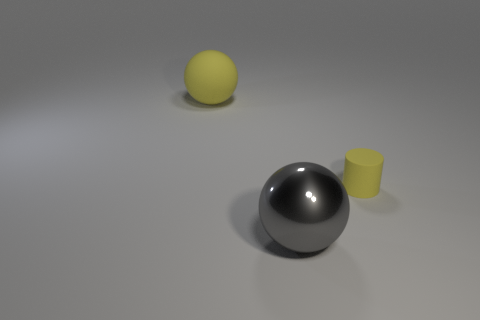What is the material of the large thing that is in front of the yellow object that is in front of the rubber ball that is left of the tiny matte cylinder?
Ensure brevity in your answer.  Metal. How many matte objects are there?
Provide a succinct answer. 2. How many purple things are either spheres or large shiny balls?
Ensure brevity in your answer.  0. What number of other objects are there of the same shape as the small yellow object?
Make the answer very short. 0. Is the color of the matte object that is to the right of the yellow rubber sphere the same as the large ball behind the tiny rubber thing?
Ensure brevity in your answer.  Yes. What number of large objects are either gray things or yellow matte spheres?
Your response must be concise. 2. What size is the matte object that is the same shape as the shiny thing?
Your answer should be very brief. Large. Are there any other things that have the same size as the cylinder?
Offer a very short reply. No. What material is the gray ball left of the cylinder right of the large matte ball?
Your answer should be compact. Metal. How many shiny objects are large gray things or tiny cylinders?
Keep it short and to the point. 1. 